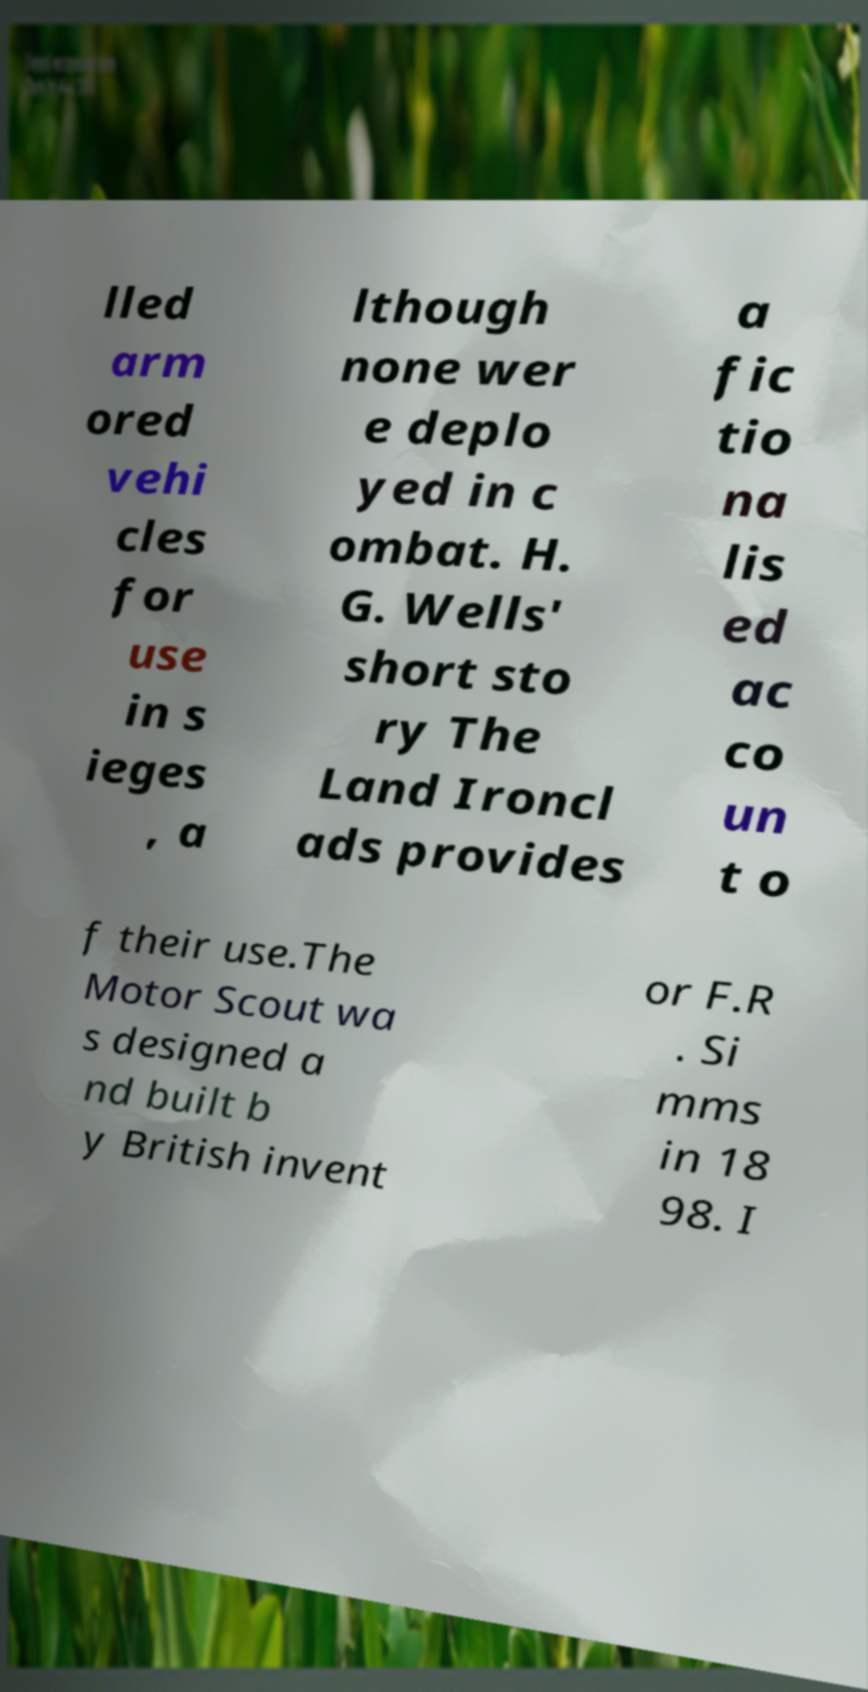Could you extract and type out the text from this image? lled arm ored vehi cles for use in s ieges , a lthough none wer e deplo yed in c ombat. H. G. Wells' short sto ry The Land Ironcl ads provides a fic tio na lis ed ac co un t o f their use.The Motor Scout wa s designed a nd built b y British invent or F.R . Si mms in 18 98. I 